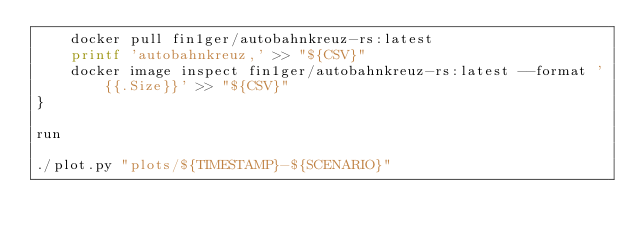<code> <loc_0><loc_0><loc_500><loc_500><_Bash_>    docker pull fin1ger/autobahnkreuz-rs:latest
    printf 'autobahnkreuz,' >> "${CSV}"
    docker image inspect fin1ger/autobahnkreuz-rs:latest --format '{{.Size}}' >> "${CSV}"
}

run

./plot.py "plots/${TIMESTAMP}-${SCENARIO}"
</code> 